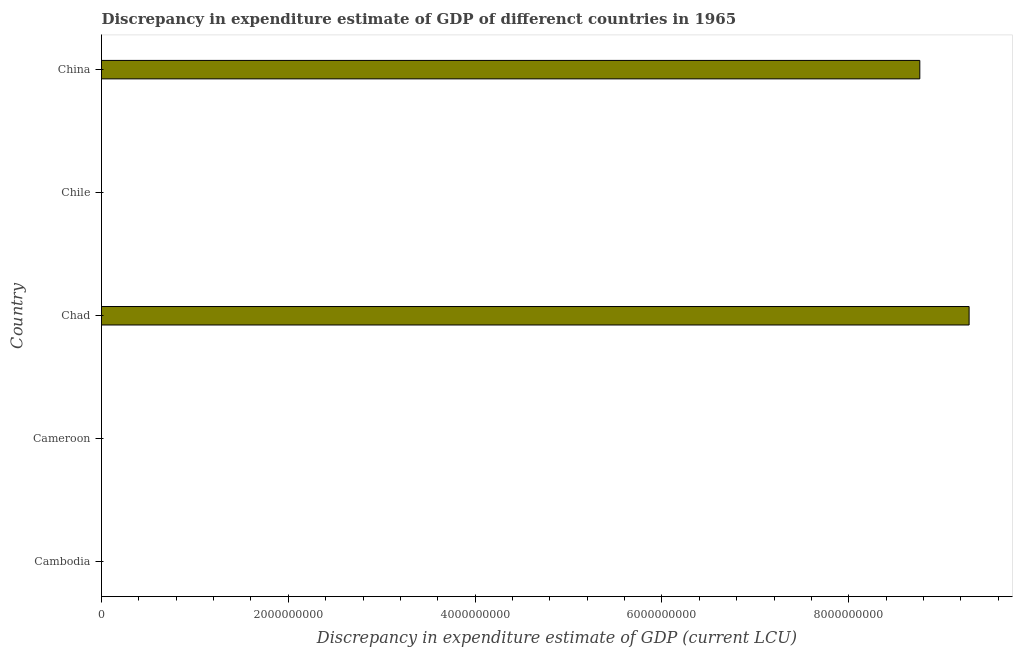Does the graph contain any zero values?
Your answer should be compact. Yes. What is the title of the graph?
Give a very brief answer. Discrepancy in expenditure estimate of GDP of differenct countries in 1965. What is the label or title of the X-axis?
Your response must be concise. Discrepancy in expenditure estimate of GDP (current LCU). Across all countries, what is the maximum discrepancy in expenditure estimate of gdp?
Offer a terse response. 9.29e+09. Across all countries, what is the minimum discrepancy in expenditure estimate of gdp?
Give a very brief answer. 0. In which country was the discrepancy in expenditure estimate of gdp maximum?
Provide a succinct answer. Chad. What is the sum of the discrepancy in expenditure estimate of gdp?
Ensure brevity in your answer.  1.80e+1. What is the difference between the discrepancy in expenditure estimate of gdp in Cambodia and China?
Offer a very short reply. -8.76e+09. What is the average discrepancy in expenditure estimate of gdp per country?
Keep it short and to the point. 3.61e+09. What is the median discrepancy in expenditure estimate of gdp?
Keep it short and to the point. 6200. In how many countries, is the discrepancy in expenditure estimate of gdp greater than 9200000000 LCU?
Offer a very short reply. 1. What is the difference between the highest and the second highest discrepancy in expenditure estimate of gdp?
Offer a terse response. 5.28e+08. Is the sum of the discrepancy in expenditure estimate of gdp in Cambodia and Chad greater than the maximum discrepancy in expenditure estimate of gdp across all countries?
Keep it short and to the point. Yes. What is the difference between the highest and the lowest discrepancy in expenditure estimate of gdp?
Provide a short and direct response. 9.29e+09. Are the values on the major ticks of X-axis written in scientific E-notation?
Give a very brief answer. No. What is the Discrepancy in expenditure estimate of GDP (current LCU) of Cambodia?
Provide a succinct answer. 600. What is the Discrepancy in expenditure estimate of GDP (current LCU) in Cameroon?
Your response must be concise. 6200. What is the Discrepancy in expenditure estimate of GDP (current LCU) in Chad?
Make the answer very short. 9.29e+09. What is the Discrepancy in expenditure estimate of GDP (current LCU) of China?
Your answer should be compact. 8.76e+09. What is the difference between the Discrepancy in expenditure estimate of GDP (current LCU) in Cambodia and Cameroon?
Ensure brevity in your answer.  -5600. What is the difference between the Discrepancy in expenditure estimate of GDP (current LCU) in Cambodia and Chad?
Make the answer very short. -9.29e+09. What is the difference between the Discrepancy in expenditure estimate of GDP (current LCU) in Cambodia and China?
Your answer should be very brief. -8.76e+09. What is the difference between the Discrepancy in expenditure estimate of GDP (current LCU) in Cameroon and Chad?
Provide a short and direct response. -9.29e+09. What is the difference between the Discrepancy in expenditure estimate of GDP (current LCU) in Cameroon and China?
Keep it short and to the point. -8.76e+09. What is the difference between the Discrepancy in expenditure estimate of GDP (current LCU) in Chad and China?
Make the answer very short. 5.28e+08. What is the ratio of the Discrepancy in expenditure estimate of GDP (current LCU) in Cambodia to that in Cameroon?
Ensure brevity in your answer.  0.1. What is the ratio of the Discrepancy in expenditure estimate of GDP (current LCU) in Cameroon to that in Chad?
Provide a succinct answer. 0. What is the ratio of the Discrepancy in expenditure estimate of GDP (current LCU) in Cameroon to that in China?
Keep it short and to the point. 0. What is the ratio of the Discrepancy in expenditure estimate of GDP (current LCU) in Chad to that in China?
Provide a succinct answer. 1.06. 